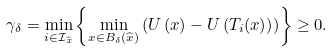Convert formula to latex. <formula><loc_0><loc_0><loc_500><loc_500>\gamma _ { \delta } = \min _ { i \in \mathcal { I } _ { \widehat { x } } } \left \{ \min _ { x \in B _ { \delta } ( \widehat { x } ) } \left ( U \left ( x \right ) - U \left ( T _ { i } ( x ) \right ) \right ) \right \} \geq 0 .</formula> 